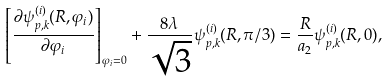<formula> <loc_0><loc_0><loc_500><loc_500>\left [ \frac { \partial \psi ^ { ( i ) } _ { p , k } ( R , \varphi _ { i } ) } { \partial \varphi _ { i } } \right ] _ { \varphi _ { i } = 0 } + \frac { 8 \lambda } { \sqrt { 3 } } \psi ^ { ( i ) } _ { p , k } ( R , \pi / 3 ) = \frac { R } { a _ { 2 } } \psi _ { p , k } ^ { ( i ) } ( R , 0 ) ,</formula> 